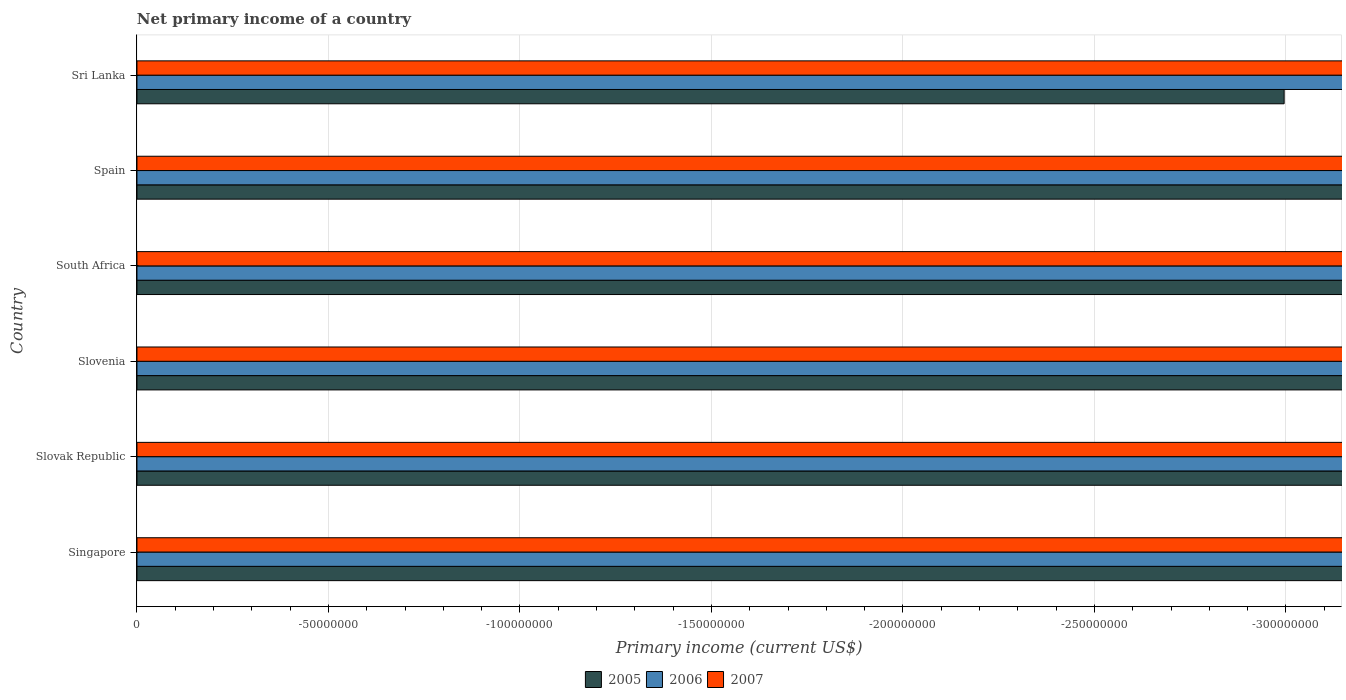How many different coloured bars are there?
Ensure brevity in your answer.  0. Are the number of bars per tick equal to the number of legend labels?
Your answer should be very brief. No. Are the number of bars on each tick of the Y-axis equal?
Offer a terse response. Yes. How many bars are there on the 5th tick from the bottom?
Offer a terse response. 0. What is the label of the 5th group of bars from the top?
Offer a very short reply. Slovak Republic. In how many cases, is the number of bars for a given country not equal to the number of legend labels?
Your answer should be very brief. 6. What is the primary income in 2007 in Slovak Republic?
Keep it short and to the point. 0. What is the difference between the primary income in 2006 in Singapore and the primary income in 2007 in Slovenia?
Give a very brief answer. 0. What is the average primary income in 2005 per country?
Make the answer very short. 0. In how many countries, is the primary income in 2007 greater than -40000000 US$?
Give a very brief answer. 0. How many bars are there?
Give a very brief answer. 0. What is the difference between two consecutive major ticks on the X-axis?
Provide a succinct answer. 5.00e+07. Are the values on the major ticks of X-axis written in scientific E-notation?
Ensure brevity in your answer.  No. Does the graph contain grids?
Ensure brevity in your answer.  Yes. Where does the legend appear in the graph?
Ensure brevity in your answer.  Bottom center. How are the legend labels stacked?
Your answer should be compact. Horizontal. What is the title of the graph?
Provide a short and direct response. Net primary income of a country. Does "2001" appear as one of the legend labels in the graph?
Offer a terse response. No. What is the label or title of the X-axis?
Your response must be concise. Primary income (current US$). What is the label or title of the Y-axis?
Provide a short and direct response. Country. What is the Primary income (current US$) of 2005 in Singapore?
Your answer should be very brief. 0. What is the Primary income (current US$) of 2006 in Singapore?
Offer a very short reply. 0. What is the Primary income (current US$) of 2007 in Singapore?
Keep it short and to the point. 0. What is the Primary income (current US$) in 2005 in Slovak Republic?
Give a very brief answer. 0. What is the Primary income (current US$) of 2007 in Slovak Republic?
Offer a very short reply. 0. What is the Primary income (current US$) of 2006 in Slovenia?
Ensure brevity in your answer.  0. What is the Primary income (current US$) of 2007 in Slovenia?
Make the answer very short. 0. What is the Primary income (current US$) of 2005 in South Africa?
Offer a very short reply. 0. What is the Primary income (current US$) in 2006 in South Africa?
Provide a succinct answer. 0. What is the Primary income (current US$) of 2005 in Spain?
Your answer should be compact. 0. What is the Primary income (current US$) of 2006 in Sri Lanka?
Offer a very short reply. 0. What is the Primary income (current US$) of 2007 in Sri Lanka?
Make the answer very short. 0. 